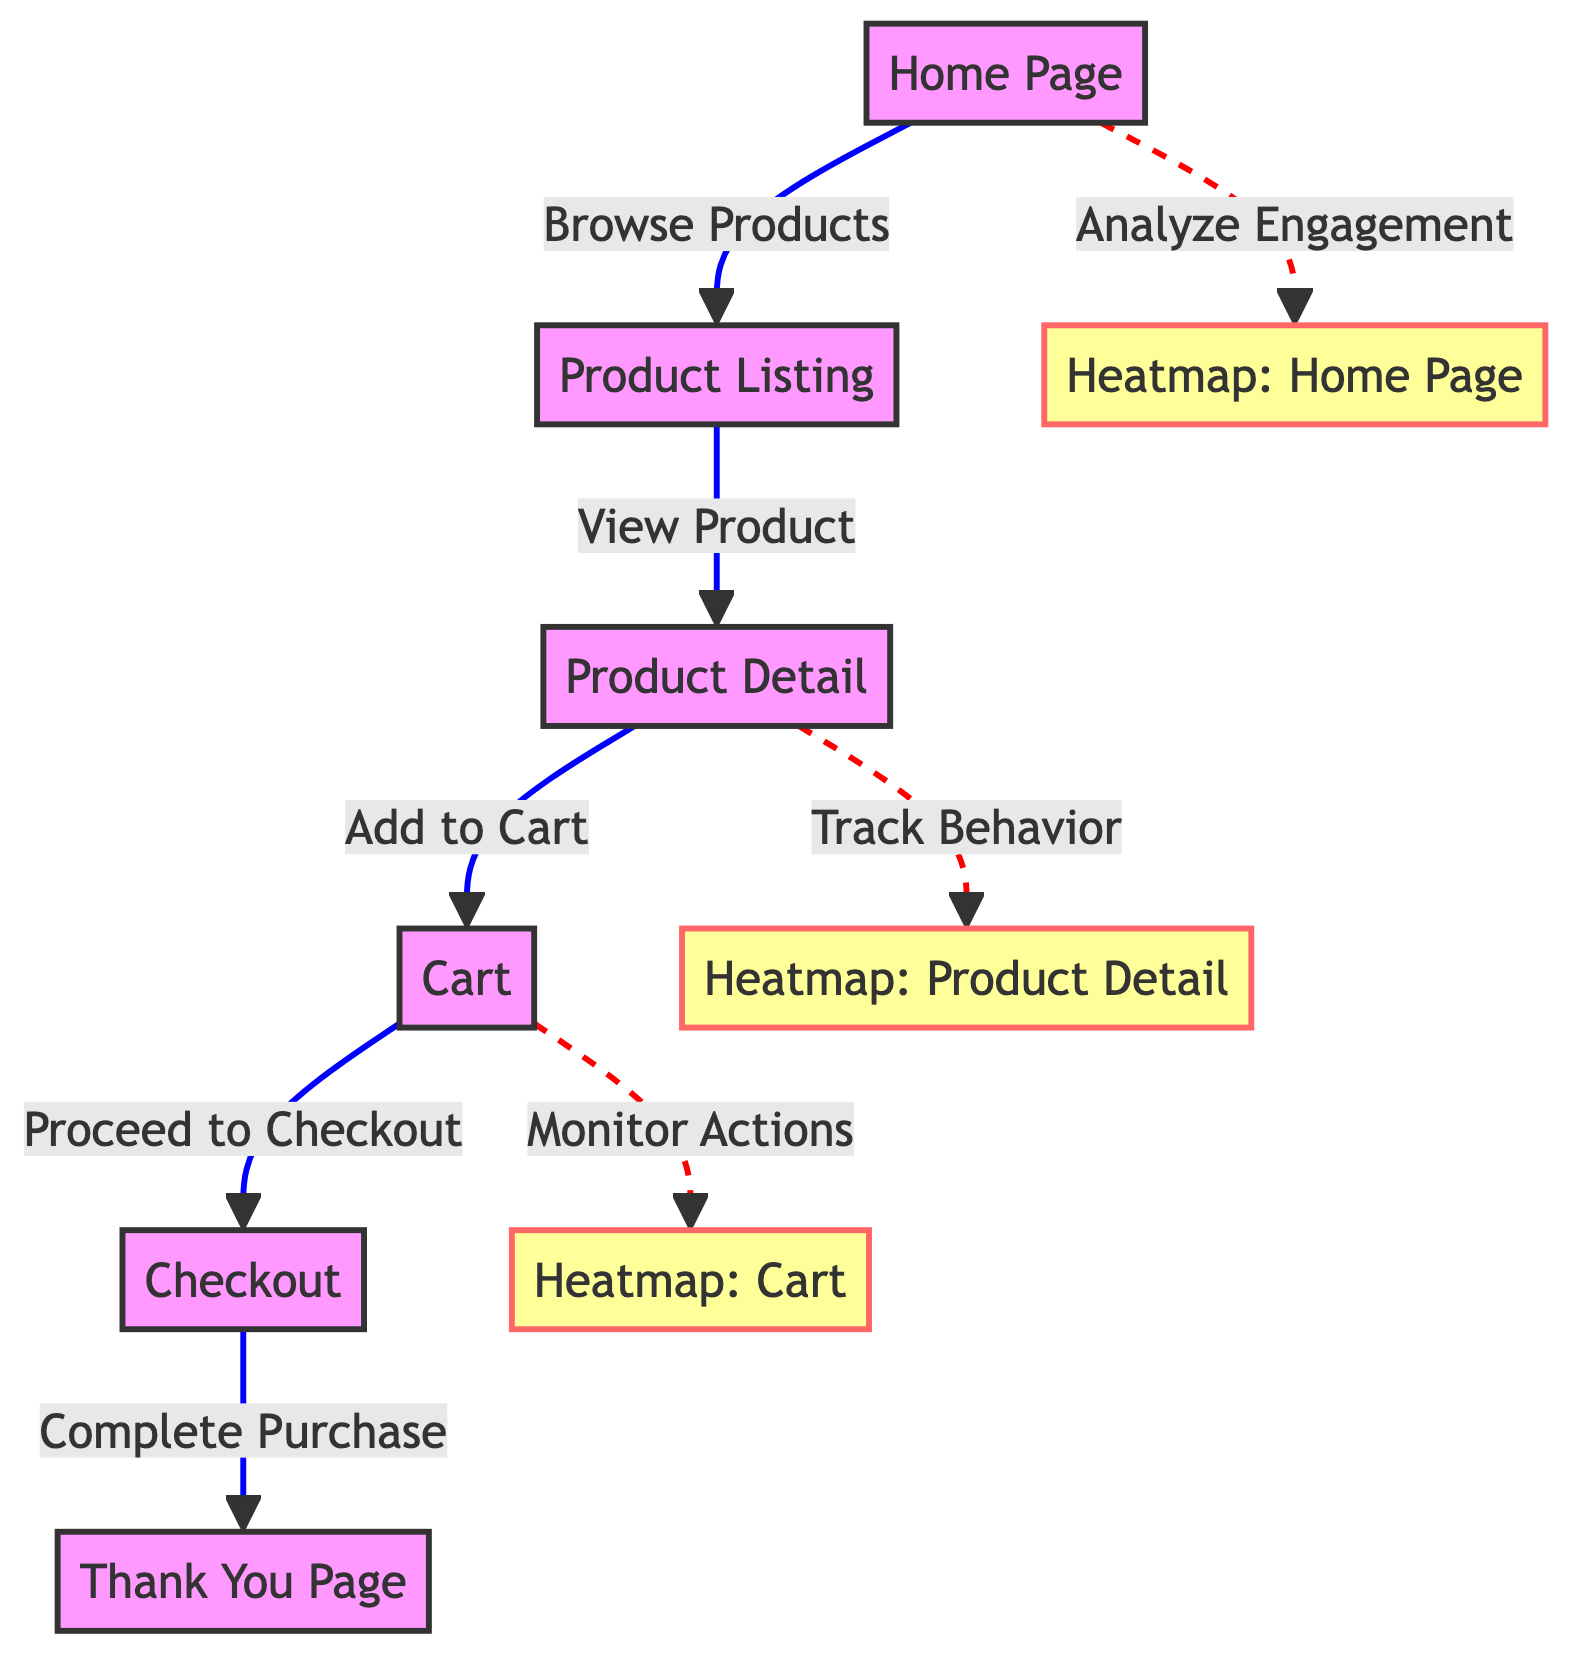What is the first step in the customer journey on the e-commerce website? The diagram shows that the first step is the "Home Page," where users start their interaction with the website.
Answer: Home Page How many nodes represent the phases of the customer journey? The diagram contains five nodes that represent the phases: Home Page, Product Listing, Product Detail, Cart, and Checkout.
Answer: Five What action follows the "Product Listing" node? According to the flow in the diagram, after "Product Listing," the next action is to "View Product," leading to the "Product Detail" node.
Answer: View Product Which node has an associated heatmap analyzing engagement? The "Home Page" node has a heatmap linked to it, indicated by the dashed connection for "Analyze Engagement."
Answer: Heatmap: Home Page What is the main purpose of the heatmap associated with the "Product Detail" node? The heatmap for the "Product Detail" node is used to "Track Behavior," which analyzes user interactions on that specific page.
Answer: Track Behavior In which stage is the user likely to abandon their purchase? Users are likely to abandon the purchase in the "Cart" stage, as it is a critical point before proceeding to checkout.
Answer: Cart What type of diagram is used to represent the flow of consumer behavior? The specified diagram type used to represent this flow is a "flowchart," which illustrates the sequential steps and actions.
Answer: Flowchart How many total edges are present in the diagram? The diagram features a total of seven edges that represent connections between different nodes and actions within the customer journey.
Answer: Seven What does the "Thank You Page" signify in the customer journey? The "Thank You Page" indicates the completion of the purchase process, providing confirmation to the user after the "Checkout" step.
Answer: Completion of Purchase 